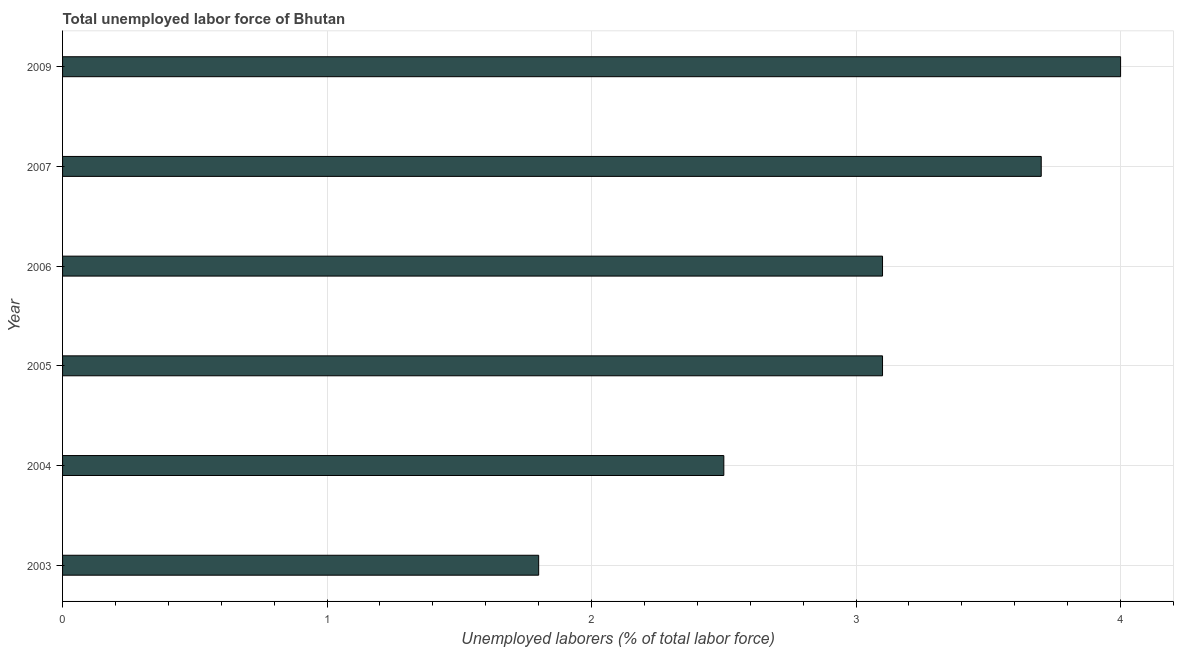Does the graph contain any zero values?
Your answer should be compact. No. What is the title of the graph?
Provide a short and direct response. Total unemployed labor force of Bhutan. What is the label or title of the X-axis?
Your response must be concise. Unemployed laborers (% of total labor force). What is the label or title of the Y-axis?
Your answer should be very brief. Year. What is the total unemployed labour force in 2006?
Your answer should be very brief. 3.1. Across all years, what is the minimum total unemployed labour force?
Offer a terse response. 1.8. What is the sum of the total unemployed labour force?
Your response must be concise. 18.2. What is the difference between the total unemployed labour force in 2003 and 2007?
Your answer should be very brief. -1.9. What is the average total unemployed labour force per year?
Your answer should be compact. 3.03. What is the median total unemployed labour force?
Make the answer very short. 3.1. What is the ratio of the total unemployed labour force in 2003 to that in 2004?
Give a very brief answer. 0.72. Is the total unemployed labour force in 2003 less than that in 2006?
Make the answer very short. Yes. Is the difference between the total unemployed labour force in 2004 and 2007 greater than the difference between any two years?
Offer a very short reply. No. What is the difference between the highest and the lowest total unemployed labour force?
Give a very brief answer. 2.2. In how many years, is the total unemployed labour force greater than the average total unemployed labour force taken over all years?
Provide a short and direct response. 4. How many bars are there?
Offer a very short reply. 6. Are all the bars in the graph horizontal?
Ensure brevity in your answer.  Yes. What is the difference between two consecutive major ticks on the X-axis?
Make the answer very short. 1. What is the Unemployed laborers (% of total labor force) of 2003?
Provide a succinct answer. 1.8. What is the Unemployed laborers (% of total labor force) in 2004?
Your response must be concise. 2.5. What is the Unemployed laborers (% of total labor force) in 2005?
Your response must be concise. 3.1. What is the Unemployed laborers (% of total labor force) of 2006?
Ensure brevity in your answer.  3.1. What is the Unemployed laborers (% of total labor force) of 2007?
Your answer should be very brief. 3.7. What is the difference between the Unemployed laborers (% of total labor force) in 2003 and 2004?
Your response must be concise. -0.7. What is the difference between the Unemployed laborers (% of total labor force) in 2003 and 2005?
Provide a succinct answer. -1.3. What is the difference between the Unemployed laborers (% of total labor force) in 2003 and 2007?
Your answer should be very brief. -1.9. What is the difference between the Unemployed laborers (% of total labor force) in 2003 and 2009?
Ensure brevity in your answer.  -2.2. What is the difference between the Unemployed laborers (% of total labor force) in 2004 and 2006?
Ensure brevity in your answer.  -0.6. What is the difference between the Unemployed laborers (% of total labor force) in 2005 and 2006?
Give a very brief answer. 0. What is the ratio of the Unemployed laborers (% of total labor force) in 2003 to that in 2004?
Provide a succinct answer. 0.72. What is the ratio of the Unemployed laborers (% of total labor force) in 2003 to that in 2005?
Keep it short and to the point. 0.58. What is the ratio of the Unemployed laborers (% of total labor force) in 2003 to that in 2006?
Offer a terse response. 0.58. What is the ratio of the Unemployed laborers (% of total labor force) in 2003 to that in 2007?
Provide a succinct answer. 0.49. What is the ratio of the Unemployed laborers (% of total labor force) in 2003 to that in 2009?
Provide a short and direct response. 0.45. What is the ratio of the Unemployed laborers (% of total labor force) in 2004 to that in 2005?
Make the answer very short. 0.81. What is the ratio of the Unemployed laborers (% of total labor force) in 2004 to that in 2006?
Provide a short and direct response. 0.81. What is the ratio of the Unemployed laborers (% of total labor force) in 2004 to that in 2007?
Offer a very short reply. 0.68. What is the ratio of the Unemployed laborers (% of total labor force) in 2004 to that in 2009?
Make the answer very short. 0.62. What is the ratio of the Unemployed laborers (% of total labor force) in 2005 to that in 2007?
Offer a very short reply. 0.84. What is the ratio of the Unemployed laborers (% of total labor force) in 2005 to that in 2009?
Make the answer very short. 0.78. What is the ratio of the Unemployed laborers (% of total labor force) in 2006 to that in 2007?
Give a very brief answer. 0.84. What is the ratio of the Unemployed laborers (% of total labor force) in 2006 to that in 2009?
Offer a very short reply. 0.78. What is the ratio of the Unemployed laborers (% of total labor force) in 2007 to that in 2009?
Make the answer very short. 0.93. 